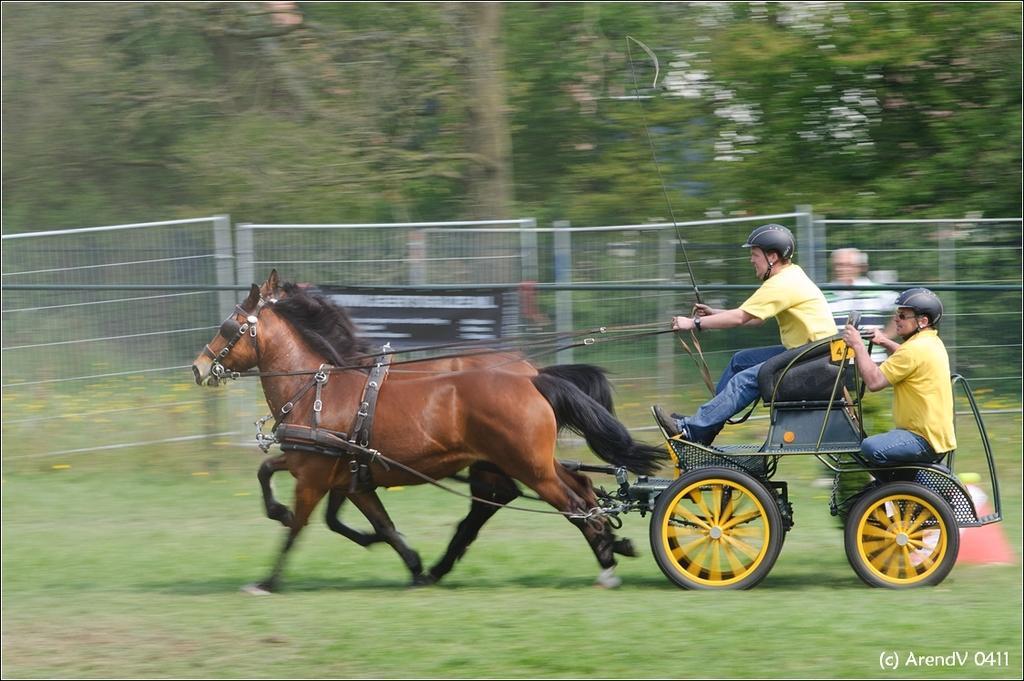Please provide a concise description of this image. In the foreground of the image, there are two person sitting on the horse cart and riding. In the middle of the image, there is a fence of rod. In the background of the image, there are trees visible and a sky is visible white in color. In the bottom of the image and both side, the grass is covered. This image is taken during day time. 